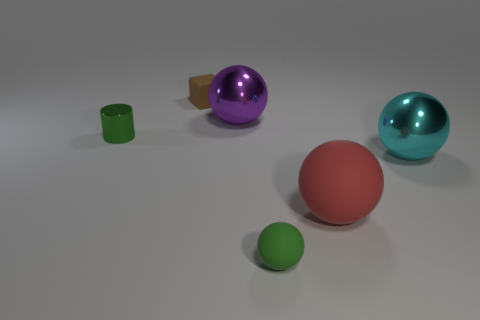Is the color of the tiny cylinder the same as the small sphere?
Your answer should be very brief. Yes. What is the color of the small thing that is behind the red object and in front of the purple shiny sphere?
Keep it short and to the point. Green. Does the rubber block that is left of the green ball have the same size as the tiny metal cylinder?
Your answer should be compact. Yes. Is there anything else that has the same shape as the brown thing?
Provide a short and direct response. No. Does the big cyan sphere have the same material as the big object on the left side of the big red matte sphere?
Provide a succinct answer. Yes. What number of purple objects are big matte balls or big metal cylinders?
Give a very brief answer. 0. Is there a purple thing?
Keep it short and to the point. Yes. Are there any large objects on the right side of the large shiny sphere on the left side of the metallic thing in front of the tiny cylinder?
Make the answer very short. Yes. Is there anything else that is the same size as the purple metal thing?
Provide a short and direct response. Yes. There is a green metallic thing; does it have the same shape as the red object in front of the cube?
Offer a terse response. No. 